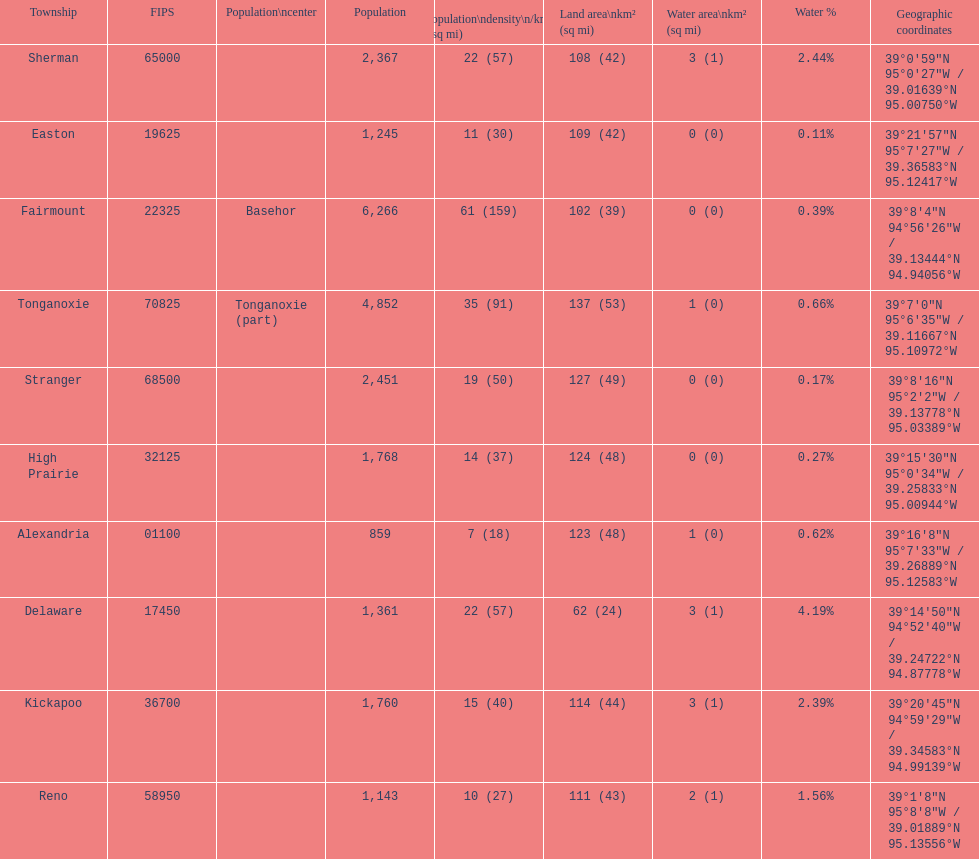Does alexandria county have a higher or lower population than delaware county? Lower. 